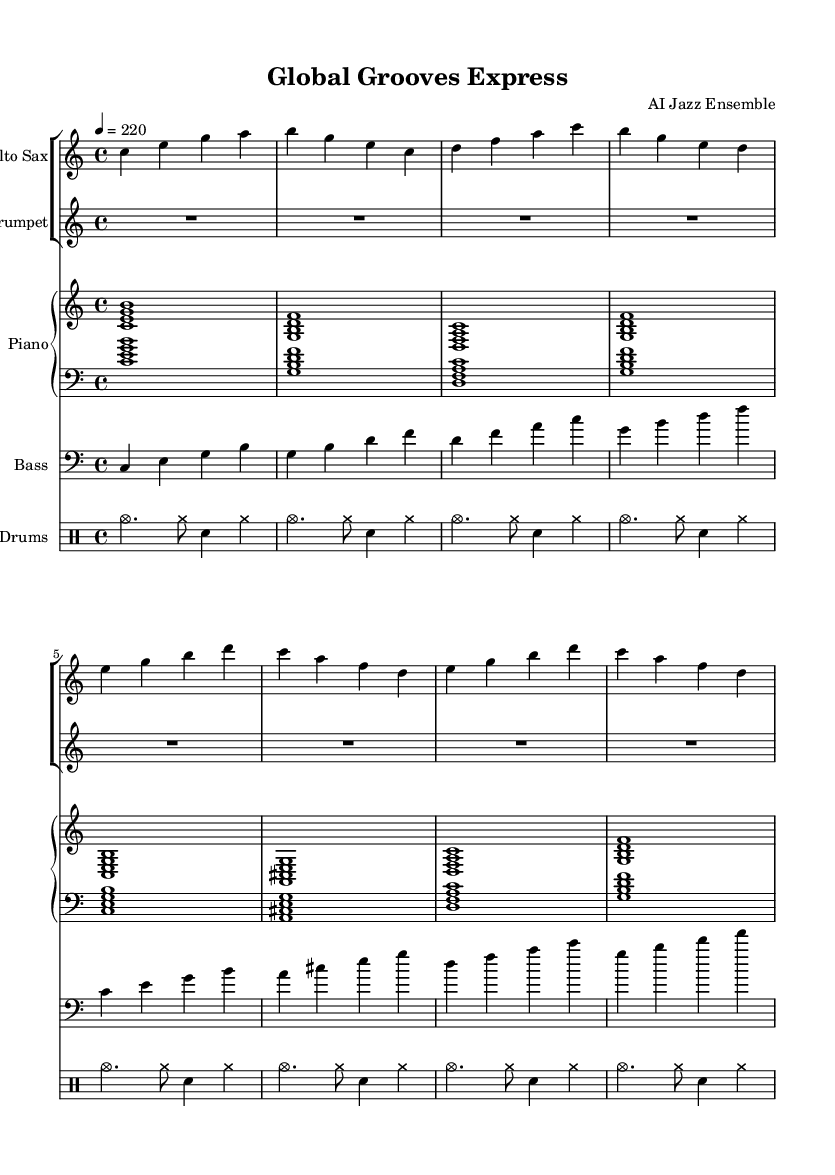What is the key signature of this music? The key signature is indicated at the beginning of the staff and shows no sharps or flats, which identifies it as C major.
Answer: C major What is the time signature of this music? The time signature is located at the start of the staff, which shows that there are four beats in a measure, represented as 4/4.
Answer: 4/4 What is the tempo marking? The tempo marking is indicated in the score, showing a tempo of quarter note equals 220 beats per minute, indicated numerically.
Answer: 220 How many measures are in the alto sax part? By counting the measures in the alto sax part, there are a total of eight measures visible in the notation.
Answer: 8 What is the structure of the piano part? The piano part is structured into chordal textures, with specific chords shown from the lower and upper staves, indicating harmony in a rhythmic pattern.
Answer: Chordal textures What instrument has a rest at the beginning of the first measure? The trumpet part starts with a whole rest, which means the instrument does not play during the first measure of the piece.
Answer: Trumpet What genre does this piece of music belong to? The lively tempo and style, along with the use of improvisational elements typically associated with specific cultural influences, confirm that it is a type of jazz music, particularly bebop.
Answer: Jazz 